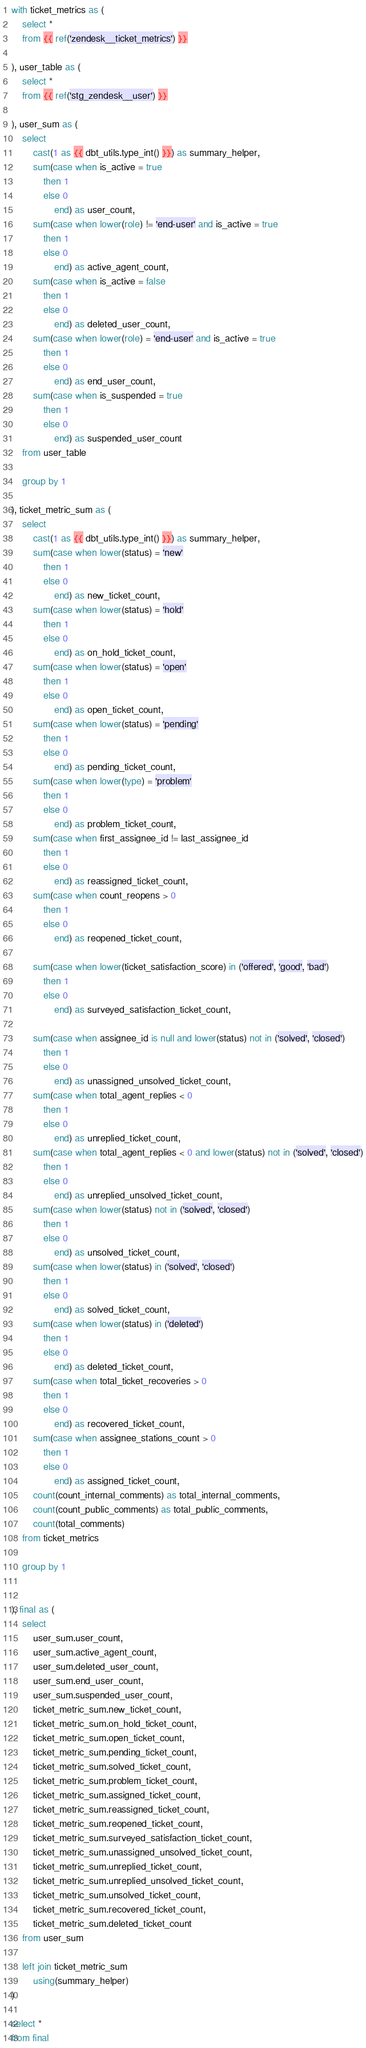Convert code to text. <code><loc_0><loc_0><loc_500><loc_500><_SQL_>with ticket_metrics as (
    select *
    from {{ ref('zendesk__ticket_metrics') }}

), user_table as (
    select *
    from {{ ref('stg_zendesk__user') }}

), user_sum as (
    select
        cast(1 as {{ dbt_utils.type_int() }}) as summary_helper,
        sum(case when is_active = true
            then 1
            else 0
                end) as user_count,
        sum(case when lower(role) != 'end-user' and is_active = true
            then 1
            else 0
                end) as active_agent_count,
        sum(case when is_active = false
            then 1
            else 0
                end) as deleted_user_count,
        sum(case when lower(role) = 'end-user' and is_active = true
            then 1
            else 0
                end) as end_user_count,
        sum(case when is_suspended = true
            then 1
            else 0
                end) as suspended_user_count
    from user_table

    group by 1

), ticket_metric_sum as (
    select 
        cast(1 as {{ dbt_utils.type_int() }}) as summary_helper,
        sum(case when lower(status) = 'new'
            then 1
            else 0
                end) as new_ticket_count,
        sum(case when lower(status) = 'hold'
            then 1
            else 0
                end) as on_hold_ticket_count,
        sum(case when lower(status) = 'open'
            then 1
            else 0
                end) as open_ticket_count,
        sum(case when lower(status) = 'pending'
            then 1
            else 0
                end) as pending_ticket_count,
        sum(case when lower(type) = 'problem'
            then 1
            else 0
                end) as problem_ticket_count,
        sum(case when first_assignee_id != last_assignee_id
            then 1
            else 0
                end) as reassigned_ticket_count,
        sum(case when count_reopens > 0
            then 1
            else 0
                end) as reopened_ticket_count,

        sum(case when lower(ticket_satisfaction_score) in ('offered', 'good', 'bad')
            then 1
            else 0
                end) as surveyed_satisfaction_ticket_count,

        sum(case when assignee_id is null and lower(status) not in ('solved', 'closed')
            then 1
            else 0
                end) as unassigned_unsolved_ticket_count,
        sum(case when total_agent_replies < 0
            then 1
            else 0
                end) as unreplied_ticket_count,
        sum(case when total_agent_replies < 0 and lower(status) not in ('solved', 'closed')
            then 1
            else 0
                end) as unreplied_unsolved_ticket_count,
        sum(case when lower(status) not in ('solved', 'closed')
            then 1
            else 0
                end) as unsolved_ticket_count,
        sum(case when lower(status) in ('solved', 'closed')
            then 1
            else 0
                end) as solved_ticket_count,
        sum(case when lower(status) in ('deleted')
            then 1
            else 0
                end) as deleted_ticket_count,
        sum(case when total_ticket_recoveries > 0
            then 1
            else 0
                end) as recovered_ticket_count,
        sum(case when assignee_stations_count > 0
            then 1
            else 0
                end) as assigned_ticket_count,
        count(count_internal_comments) as total_internal_comments,
        count(count_public_comments) as total_public_comments,
        count(total_comments)
    from ticket_metrics
    
    group by 1


), final as (
    select
        user_sum.user_count,
        user_sum.active_agent_count,
        user_sum.deleted_user_count,
        user_sum.end_user_count,
        user_sum.suspended_user_count,
        ticket_metric_sum.new_ticket_count,
        ticket_metric_sum.on_hold_ticket_count,
        ticket_metric_sum.open_ticket_count,
        ticket_metric_sum.pending_ticket_count,
        ticket_metric_sum.solved_ticket_count,
        ticket_metric_sum.problem_ticket_count,
        ticket_metric_sum.assigned_ticket_count,
        ticket_metric_sum.reassigned_ticket_count,
        ticket_metric_sum.reopened_ticket_count,
        ticket_metric_sum.surveyed_satisfaction_ticket_count,
        ticket_metric_sum.unassigned_unsolved_ticket_count,
        ticket_metric_sum.unreplied_ticket_count,
        ticket_metric_sum.unreplied_unsolved_ticket_count,
        ticket_metric_sum.unsolved_ticket_count,
        ticket_metric_sum.recovered_ticket_count,
        ticket_metric_sum.deleted_ticket_count
    from user_sum

    left join ticket_metric_sum
        using(summary_helper)
)

select *
from final</code> 